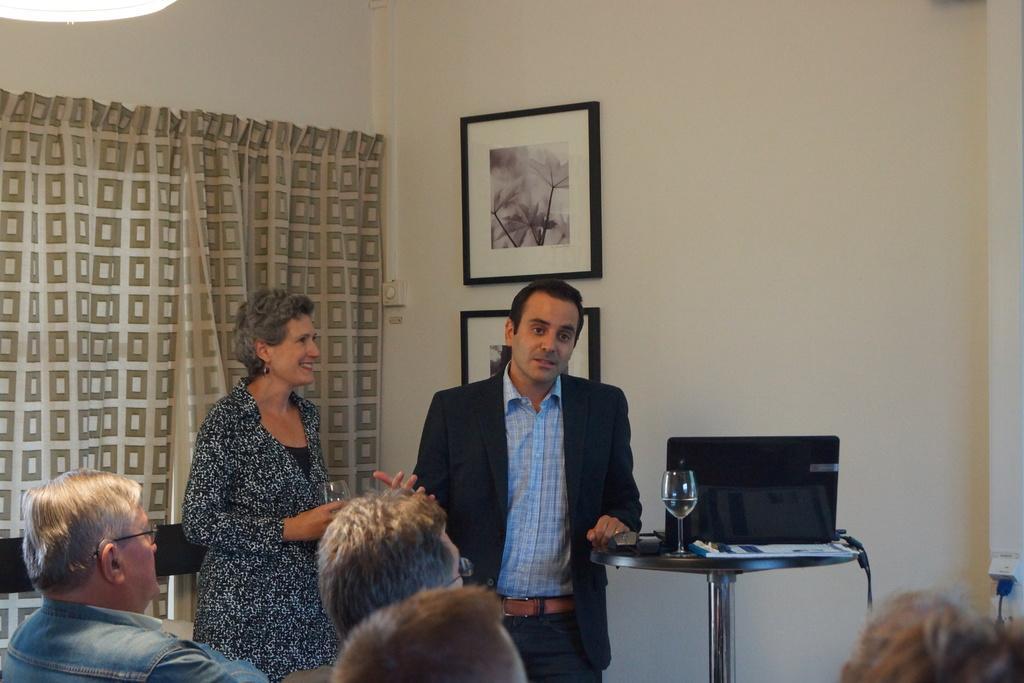Can you describe this image briefly? There is a group of persons are at the bottom left side of this image and there is a wall in the background. There is a curtain on the left side of this image and there are two photo frames are attached on the wall. There is one glass and a bag is kept on a table on the right side of this image. 